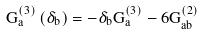Convert formula to latex. <formula><loc_0><loc_0><loc_500><loc_500>G _ { a } ^ { \left ( 3 \right ) } \left ( \delta _ { b } \right ) = - \delta _ { b } G _ { a } ^ { \left ( 3 \right ) } - 6 G _ { a b } ^ { \left ( 2 \right ) }</formula> 